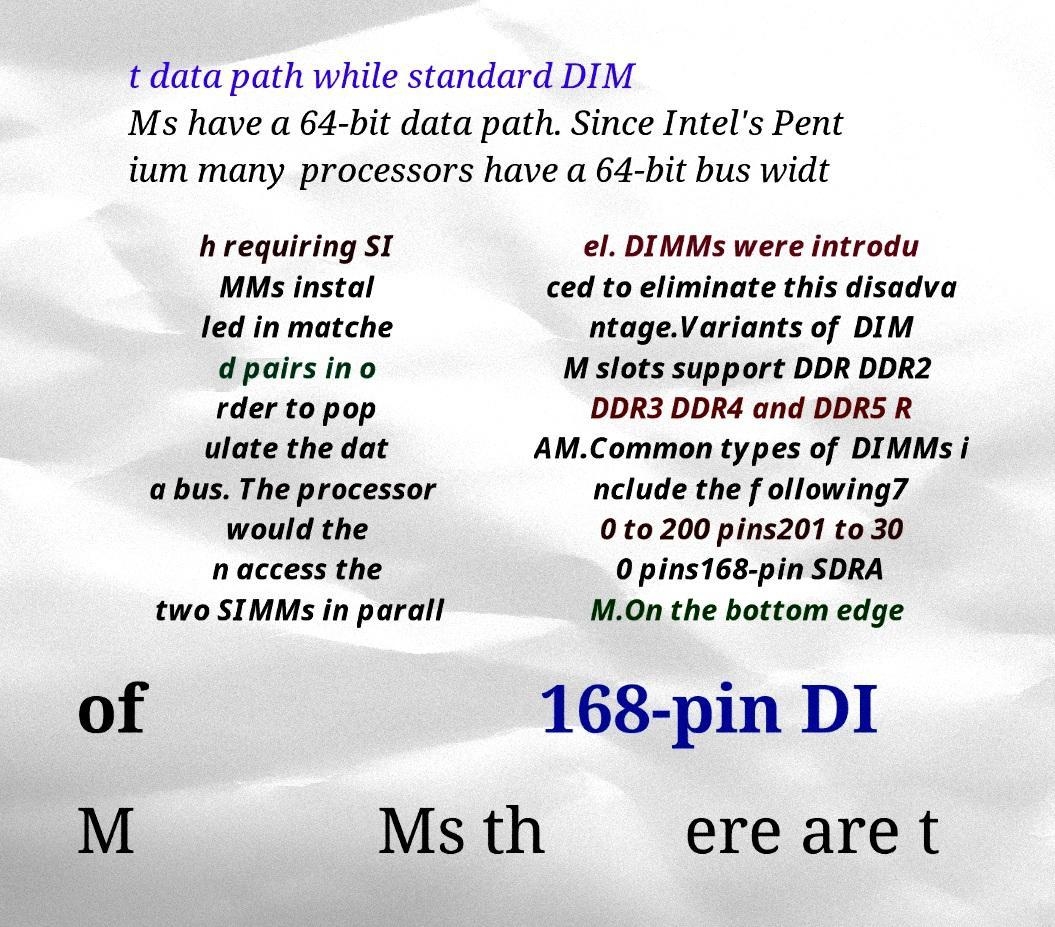What messages or text are displayed in this image? I need them in a readable, typed format. t data path while standard DIM Ms have a 64-bit data path. Since Intel's Pent ium many processors have a 64-bit bus widt h requiring SI MMs instal led in matche d pairs in o rder to pop ulate the dat a bus. The processor would the n access the two SIMMs in parall el. DIMMs were introdu ced to eliminate this disadva ntage.Variants of DIM M slots support DDR DDR2 DDR3 DDR4 and DDR5 R AM.Common types of DIMMs i nclude the following7 0 to 200 pins201 to 30 0 pins168-pin SDRA M.On the bottom edge of 168-pin DI M Ms th ere are t 